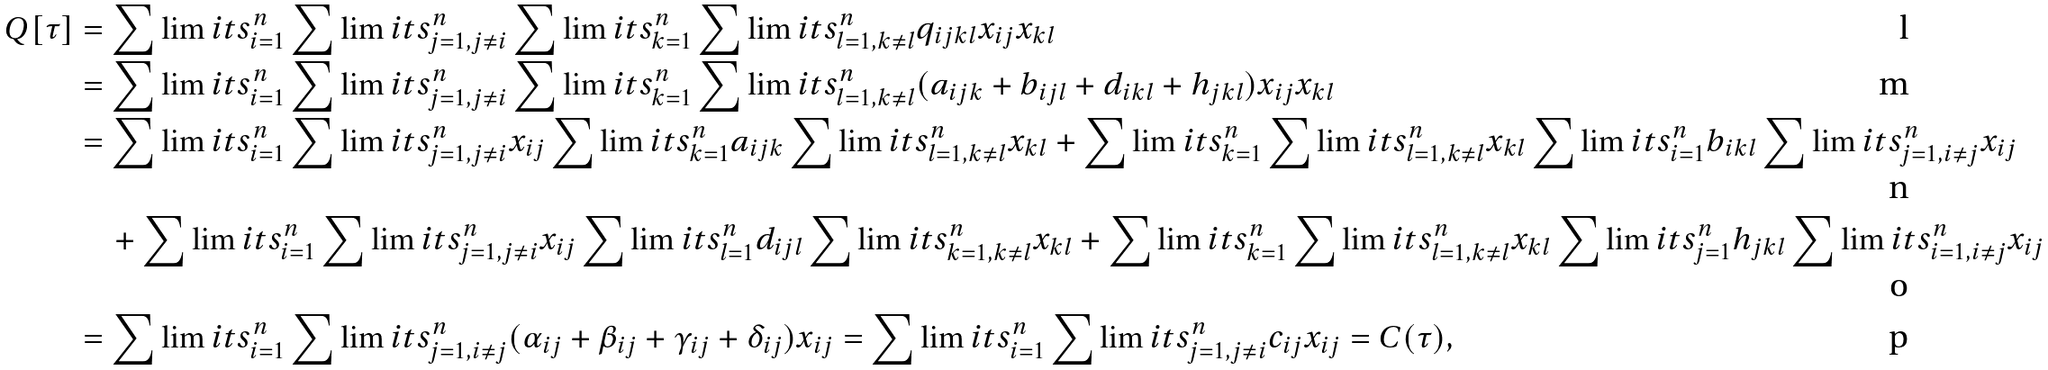Convert formula to latex. <formula><loc_0><loc_0><loc_500><loc_500>Q [ \tau ] & = \sum \lim i t s _ { i = 1 } ^ { n } \sum \lim i t s _ { j = 1 , j \neq i } ^ { n } \sum \lim i t s _ { k = 1 } ^ { n } \sum \lim i t s _ { l = 1 , k \neq l } ^ { n } q _ { i j k l } x _ { i j } x _ { k l } \\ & = \sum \lim i t s _ { i = 1 } ^ { n } \sum \lim i t s _ { j = 1 , j \neq i } ^ { n } \sum \lim i t s _ { k = 1 } ^ { n } \sum \lim i t s _ { l = 1 , k \neq l } ^ { n } ( a _ { i j k } + b _ { i j l } + d _ { i k l } + h _ { j k l } ) x _ { i j } x _ { k l } \\ & = \sum \lim i t s _ { i = 1 } ^ { n } \sum \lim i t s _ { j = 1 , j \neq i } ^ { n } x _ { i j } \sum \lim i t s _ { k = 1 } ^ { n } a _ { i j k } \sum \lim i t s _ { l = 1 , k \neq l } ^ { n } x _ { k l } + \sum \lim i t s _ { k = 1 } ^ { n } \sum \lim i t s _ { l = 1 , k \neq l } ^ { n } x _ { k l } \sum \lim i t s _ { i = 1 } ^ { n } b _ { i k l } \sum \lim i t s _ { j = 1 , i \neq j } ^ { n } x _ { i j } \\ & \quad + \sum \lim i t s _ { i = 1 } ^ { n } \sum \lim i t s _ { j = 1 , j \neq i } ^ { n } x _ { i j } \sum \lim i t s _ { l = 1 } ^ { n } d _ { i j l } \sum \lim i t s _ { k = 1 , k \neq l } ^ { n } x _ { k l } + \sum \lim i t s _ { k = 1 } ^ { n } \sum \lim i t s _ { l = 1 , k \neq l } ^ { n } x _ { k l } \sum \lim i t s _ { j = 1 } ^ { n } h _ { j k l } \sum \lim i t s _ { i = 1 , i \neq j } ^ { n } x _ { i j } \\ & = \sum \lim i t s _ { i = 1 } ^ { n } \sum \lim i t s _ { j = 1 , i \neq j } ^ { n } ( \alpha _ { i j } + \beta _ { i j } + \gamma _ { i j } + \delta _ { i j } ) x _ { i j } = \sum \lim i t s _ { i = 1 } ^ { n } \sum \lim i t s _ { j = 1 , j \neq i } ^ { n } c _ { i j } x _ { i j } = C ( \tau ) ,</formula> 